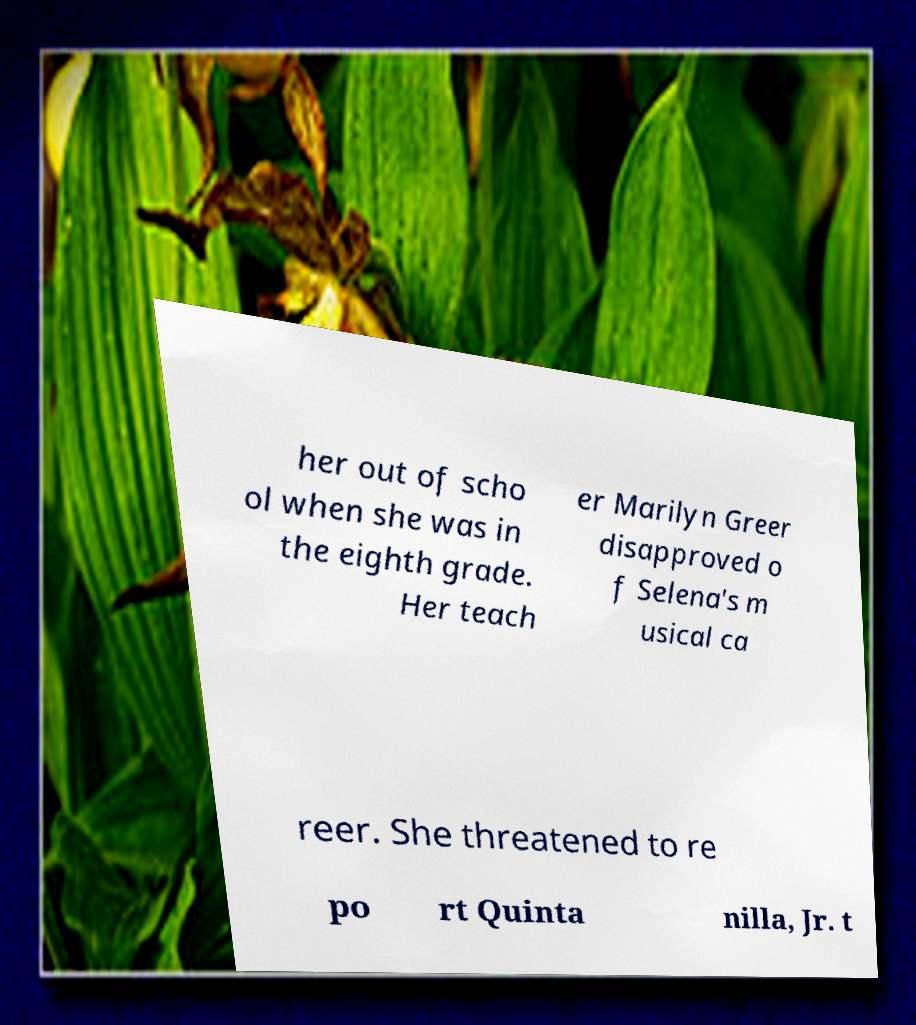Could you assist in decoding the text presented in this image and type it out clearly? her out of scho ol when she was in the eighth grade. Her teach er Marilyn Greer disapproved o f Selena's m usical ca reer. She threatened to re po rt Quinta nilla, Jr. t 